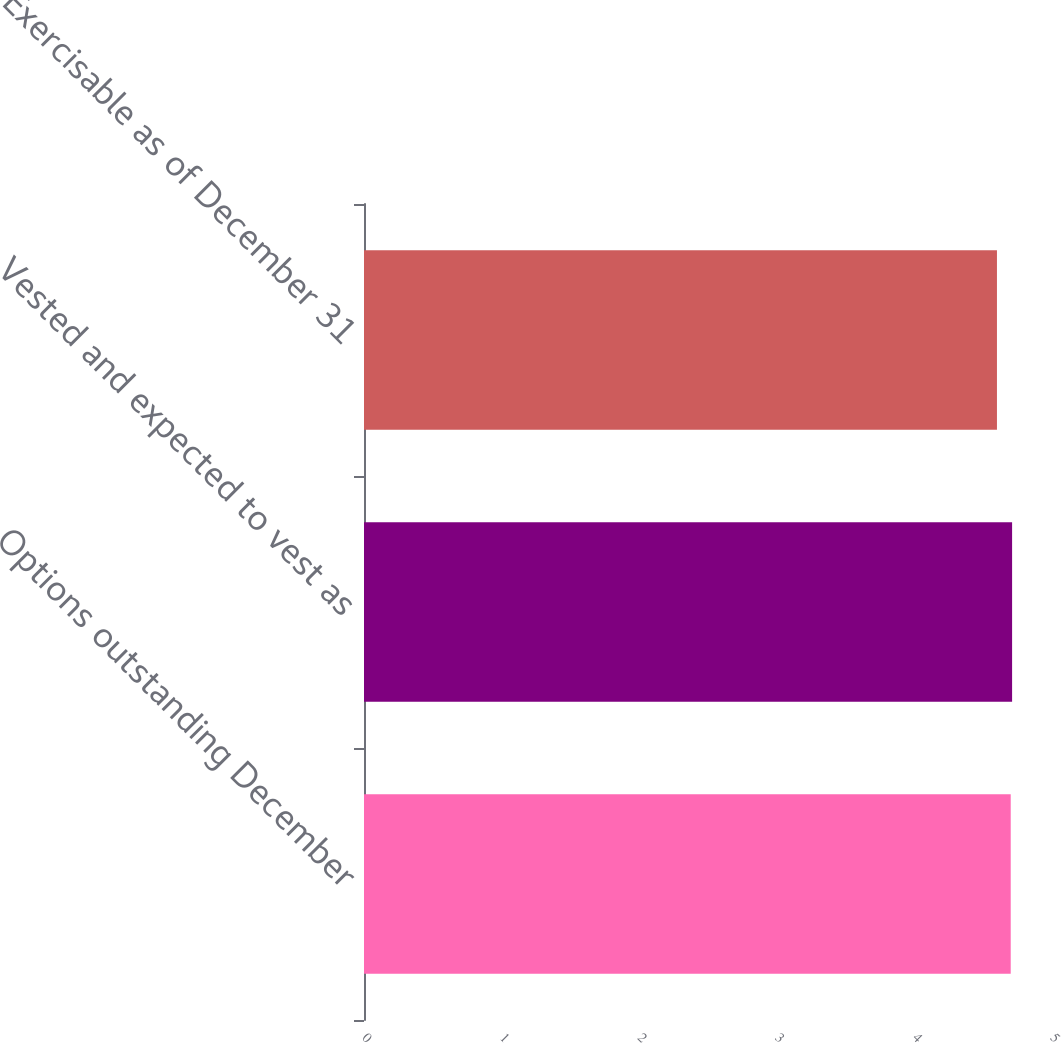<chart> <loc_0><loc_0><loc_500><loc_500><bar_chart><fcel>Options outstanding December<fcel>Vested and expected to vest as<fcel>Exercisable as of December 31<nl><fcel>4.7<fcel>4.71<fcel>4.6<nl></chart> 